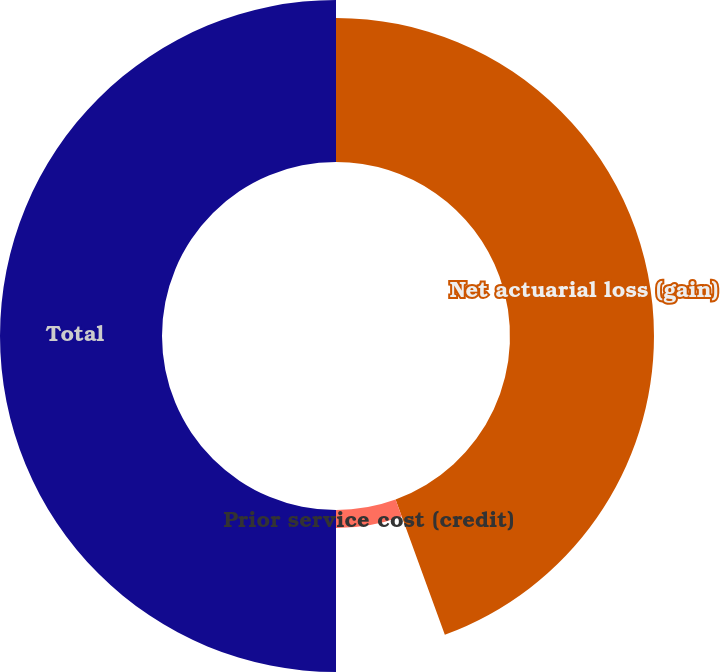Convert chart to OTSL. <chart><loc_0><loc_0><loc_500><loc_500><pie_chart><fcel>Net actuarial loss (gain)<fcel>Prior service cost (credit)<fcel>Total<nl><fcel>44.44%<fcel>5.56%<fcel>50.0%<nl></chart> 